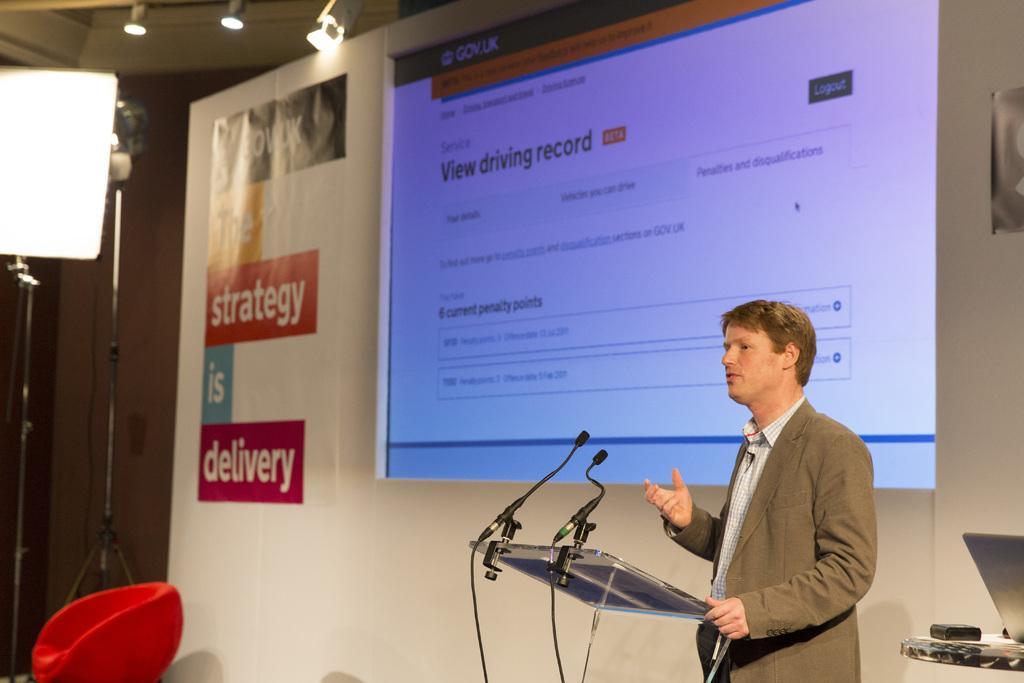How would you summarize this image in a sentence or two? In this image in the front there is a podium and on the top of the podium there are mics. In the center there is a person standing and speaking. In the background there is a screen and there is a banner with some text written on it, there are lights and there is an empty couch. On the right side there is a laptop on the table and there is an object which is black in colour. 